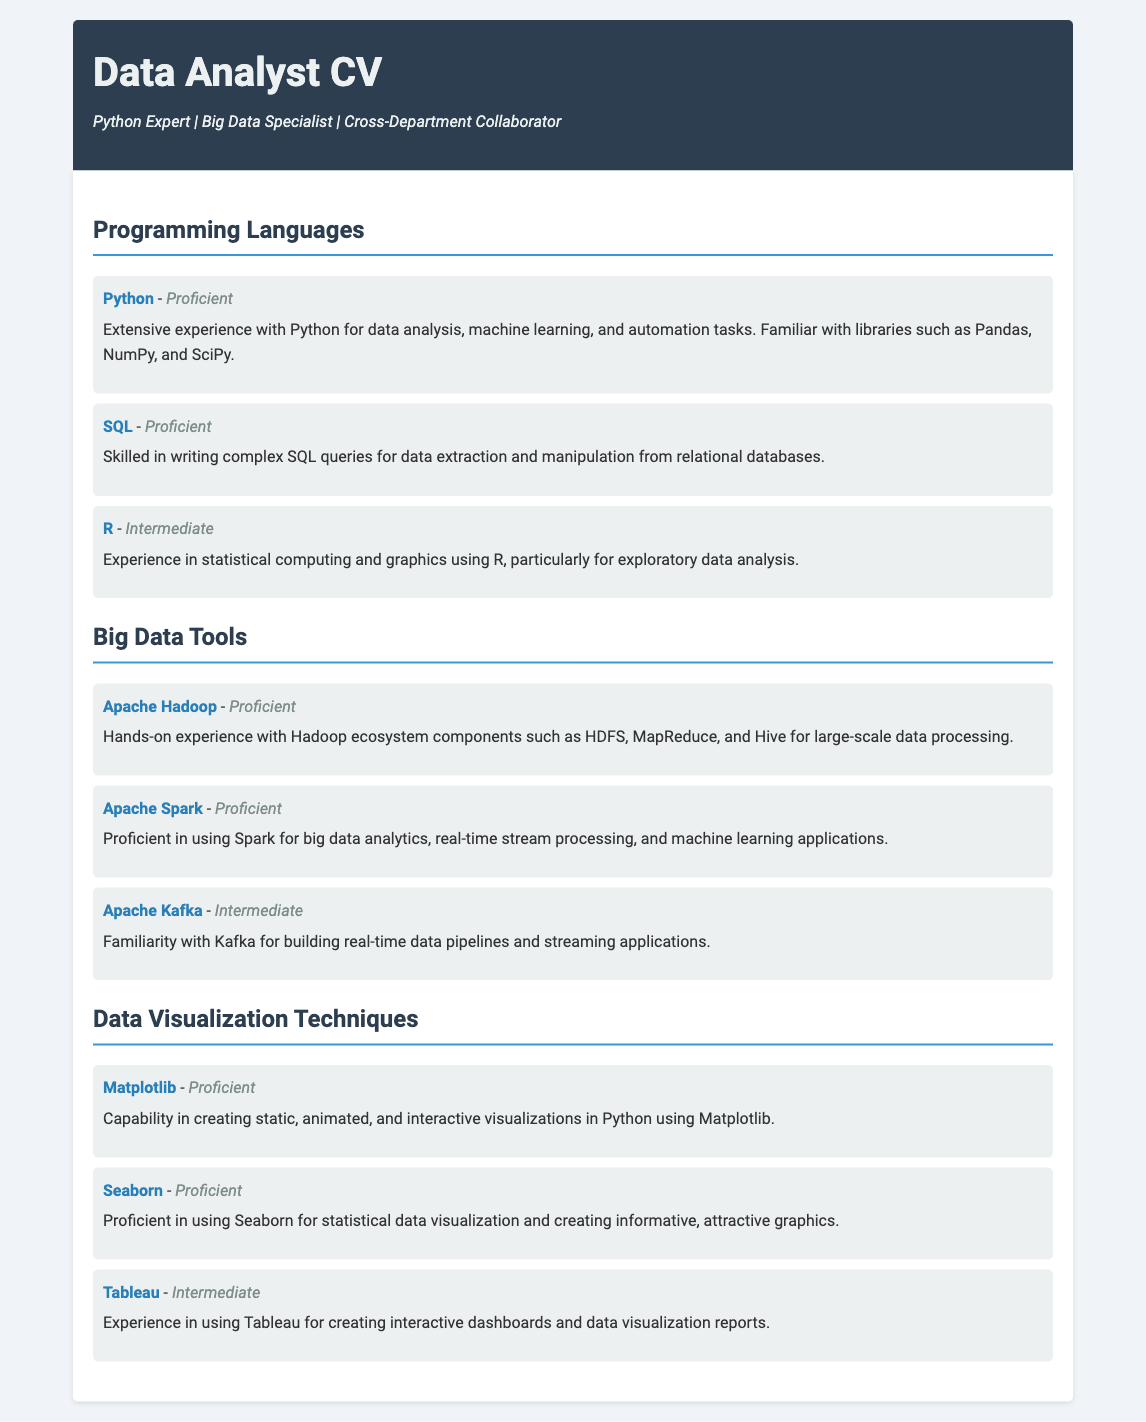What is the primary programming language mentioned? The curriculum vitae highlights Python as the primary programming language in the skills section.
Answer: Python How many Big Data tools are listed? The document includes three Big Data tools: Apache Hadoop, Apache Spark, and Apache Kafka.
Answer: Three What is the proficiency level of the candidate in SQL? The document specifies that the candidate is proficient in SQL, as stated in the "Programming Languages" section.
Answer: Proficient Which data visualization tool has the highest proficiency? The document lists both Matplotlib and Seaborn as proficient tools, but they are equally rated in terms of proficiency.
Answer: Matplotlib, Seaborn What is the skill level in Apache Kafka? The curriculum vitae indicates an intermediate proficiency level in Apache Kafka under the "Big Data Tools" section.
Answer: Intermediate What programming language is the candidate intermediate in? The candidate is intermediate in R, as indicated in the "Programming Languages" section.
Answer: R Which data visualization technique is specifically mentioned for creating interactive visualizations? The document refers to Matplotlib as capable of creating static, animated, and interactive visualizations.
Answer: Matplotlib What is the candidate's experience with Tableau? The document states that the candidate has intermediate experience with Tableau for creating interactive dashboards.
Answer: Intermediate 